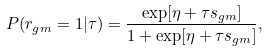Convert formula to latex. <formula><loc_0><loc_0><loc_500><loc_500>P ( r _ { g m } = 1 | \tau ) = \frac { \exp [ \eta + \tau s _ { g m } ] } { 1 + \exp [ \eta + \tau s _ { g m } ] } ,</formula> 